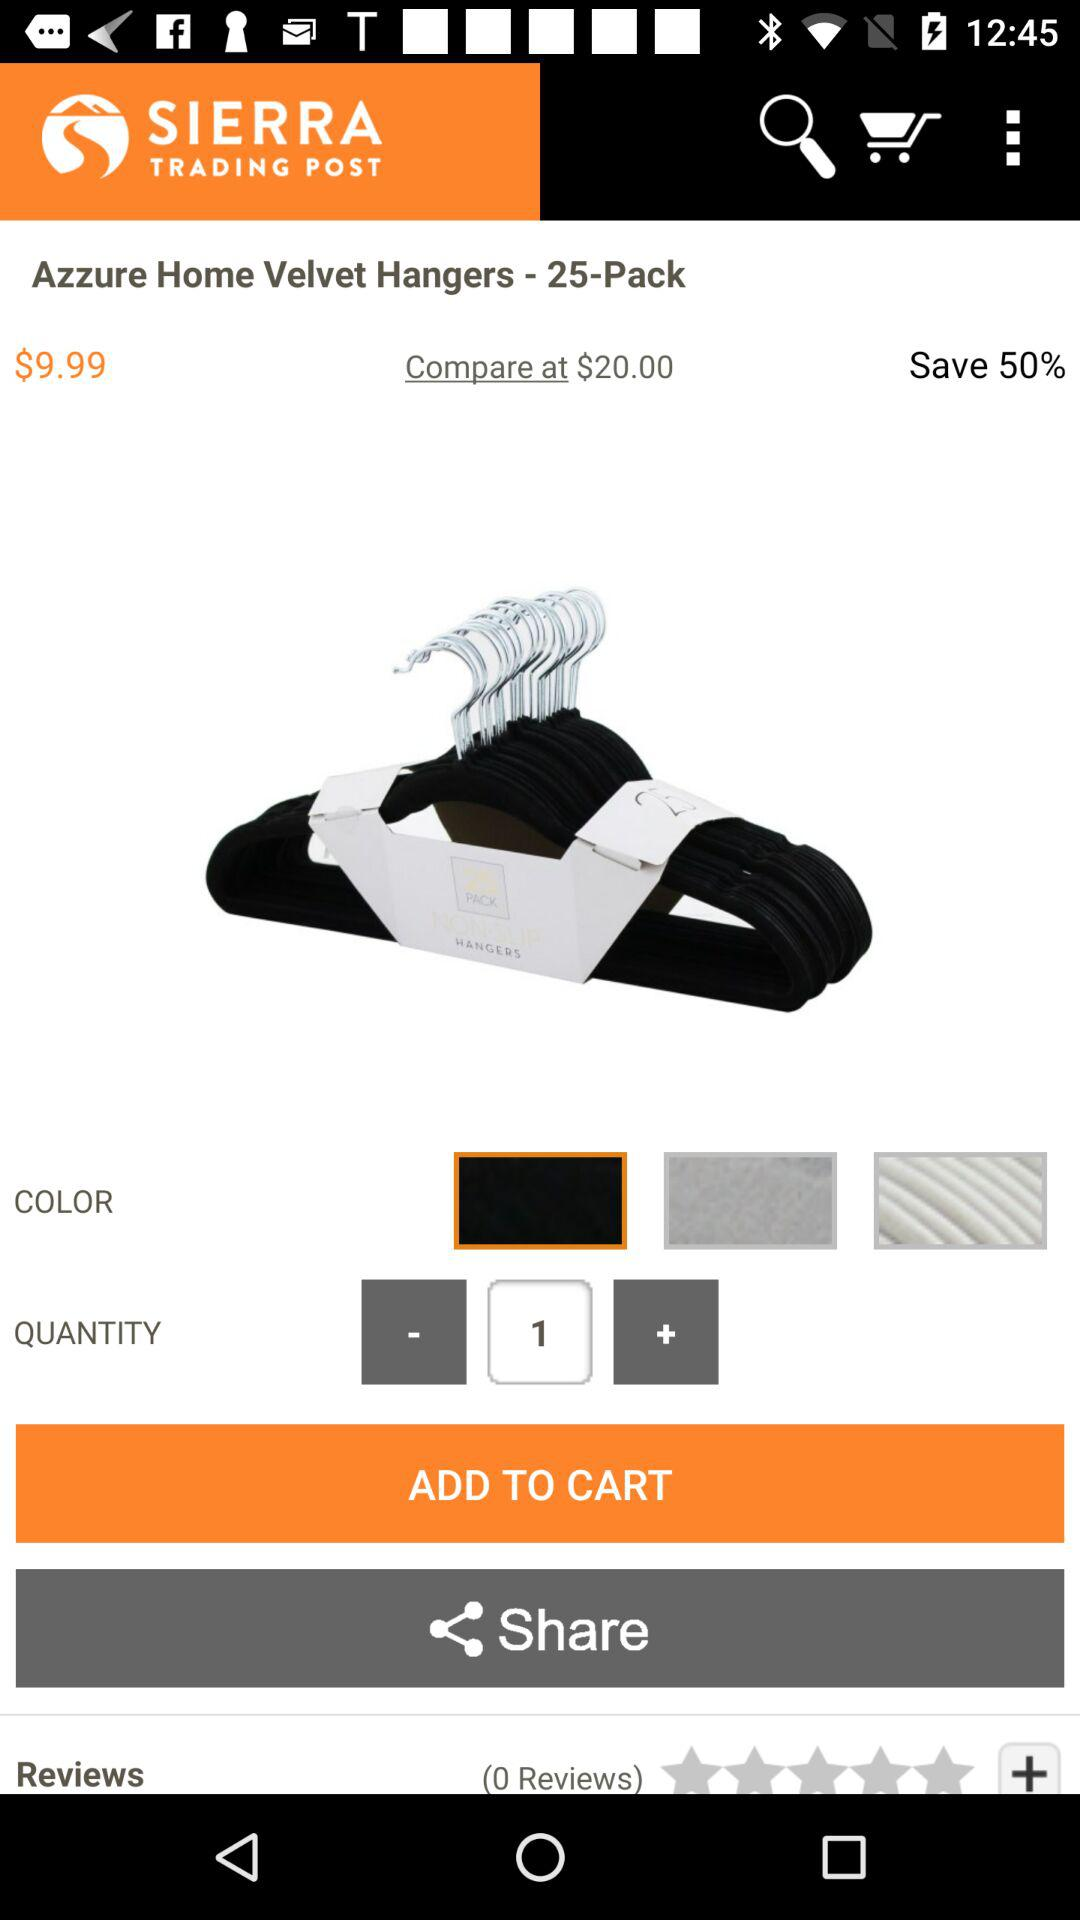How much is the product on sale for?
Answer the question using a single word or phrase. $9.99 